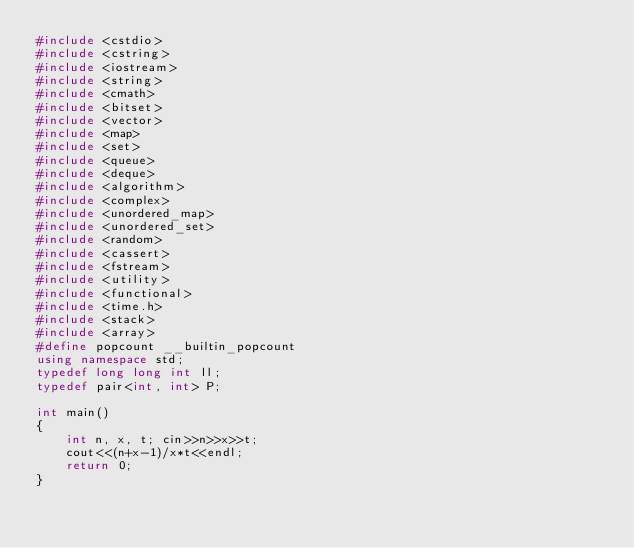<code> <loc_0><loc_0><loc_500><loc_500><_C++_>#include <cstdio>
#include <cstring>
#include <iostream>
#include <string>
#include <cmath>
#include <bitset>
#include <vector>
#include <map>
#include <set>
#include <queue>
#include <deque>
#include <algorithm>
#include <complex>
#include <unordered_map>
#include <unordered_set>
#include <random>
#include <cassert>
#include <fstream>
#include <utility>
#include <functional>
#include <time.h>
#include <stack>
#include <array>
#define popcount __builtin_popcount
using namespace std;
typedef long long int ll;
typedef pair<int, int> P;

int main()
{
    int n, x, t; cin>>n>>x>>t;
    cout<<(n+x-1)/x*t<<endl;
    return 0;
}</code> 